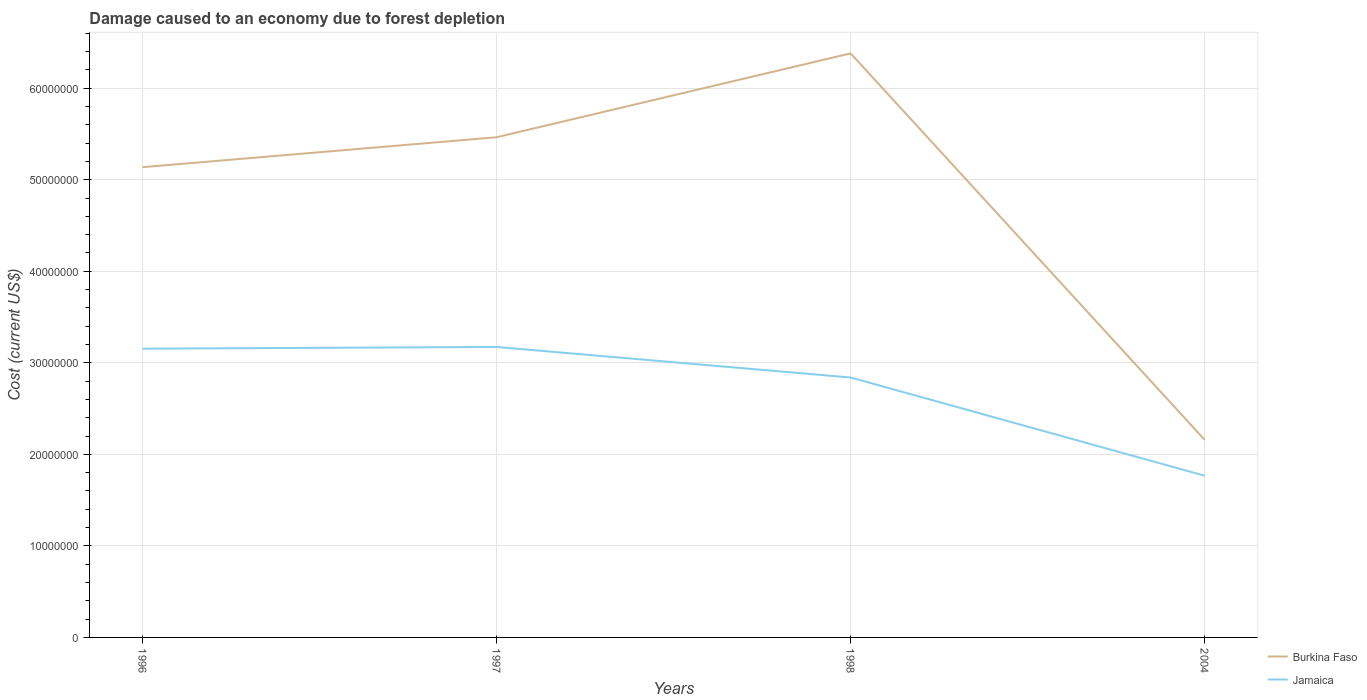How many different coloured lines are there?
Provide a succinct answer. 2. Does the line corresponding to Burkina Faso intersect with the line corresponding to Jamaica?
Give a very brief answer. No. Across all years, what is the maximum cost of damage caused due to forest depletion in Burkina Faso?
Provide a succinct answer. 2.16e+07. What is the total cost of damage caused due to forest depletion in Burkina Faso in the graph?
Give a very brief answer. 2.98e+07. What is the difference between the highest and the second highest cost of damage caused due to forest depletion in Jamaica?
Keep it short and to the point. 1.41e+07. How many lines are there?
Ensure brevity in your answer.  2. How many years are there in the graph?
Your answer should be very brief. 4. Does the graph contain any zero values?
Ensure brevity in your answer.  No. How many legend labels are there?
Your response must be concise. 2. What is the title of the graph?
Your answer should be compact. Damage caused to an economy due to forest depletion. Does "St. Lucia" appear as one of the legend labels in the graph?
Ensure brevity in your answer.  No. What is the label or title of the Y-axis?
Give a very brief answer. Cost (current US$). What is the Cost (current US$) in Burkina Faso in 1996?
Offer a terse response. 5.14e+07. What is the Cost (current US$) of Jamaica in 1996?
Your answer should be very brief. 3.15e+07. What is the Cost (current US$) of Burkina Faso in 1997?
Offer a very short reply. 5.46e+07. What is the Cost (current US$) in Jamaica in 1997?
Offer a very short reply. 3.17e+07. What is the Cost (current US$) of Burkina Faso in 1998?
Offer a terse response. 6.38e+07. What is the Cost (current US$) in Jamaica in 1998?
Provide a succinct answer. 2.84e+07. What is the Cost (current US$) in Burkina Faso in 2004?
Provide a short and direct response. 2.16e+07. What is the Cost (current US$) of Jamaica in 2004?
Provide a succinct answer. 1.77e+07. Across all years, what is the maximum Cost (current US$) in Burkina Faso?
Your response must be concise. 6.38e+07. Across all years, what is the maximum Cost (current US$) in Jamaica?
Ensure brevity in your answer.  3.17e+07. Across all years, what is the minimum Cost (current US$) of Burkina Faso?
Ensure brevity in your answer.  2.16e+07. Across all years, what is the minimum Cost (current US$) in Jamaica?
Make the answer very short. 1.77e+07. What is the total Cost (current US$) of Burkina Faso in the graph?
Provide a succinct answer. 1.91e+08. What is the total Cost (current US$) in Jamaica in the graph?
Offer a terse response. 1.09e+08. What is the difference between the Cost (current US$) in Burkina Faso in 1996 and that in 1997?
Provide a succinct answer. -3.27e+06. What is the difference between the Cost (current US$) of Jamaica in 1996 and that in 1997?
Your answer should be compact. -1.87e+05. What is the difference between the Cost (current US$) of Burkina Faso in 1996 and that in 1998?
Your answer should be very brief. -1.24e+07. What is the difference between the Cost (current US$) of Jamaica in 1996 and that in 1998?
Ensure brevity in your answer.  3.15e+06. What is the difference between the Cost (current US$) in Burkina Faso in 1996 and that in 2004?
Give a very brief answer. 2.98e+07. What is the difference between the Cost (current US$) of Jamaica in 1996 and that in 2004?
Your answer should be very brief. 1.39e+07. What is the difference between the Cost (current US$) in Burkina Faso in 1997 and that in 1998?
Offer a very short reply. -9.16e+06. What is the difference between the Cost (current US$) in Jamaica in 1997 and that in 1998?
Offer a terse response. 3.34e+06. What is the difference between the Cost (current US$) in Burkina Faso in 1997 and that in 2004?
Your answer should be very brief. 3.31e+07. What is the difference between the Cost (current US$) of Jamaica in 1997 and that in 2004?
Give a very brief answer. 1.41e+07. What is the difference between the Cost (current US$) of Burkina Faso in 1998 and that in 2004?
Your answer should be very brief. 4.22e+07. What is the difference between the Cost (current US$) in Jamaica in 1998 and that in 2004?
Your answer should be very brief. 1.07e+07. What is the difference between the Cost (current US$) in Burkina Faso in 1996 and the Cost (current US$) in Jamaica in 1997?
Your response must be concise. 1.96e+07. What is the difference between the Cost (current US$) of Burkina Faso in 1996 and the Cost (current US$) of Jamaica in 1998?
Your response must be concise. 2.30e+07. What is the difference between the Cost (current US$) in Burkina Faso in 1996 and the Cost (current US$) in Jamaica in 2004?
Your response must be concise. 3.37e+07. What is the difference between the Cost (current US$) in Burkina Faso in 1997 and the Cost (current US$) in Jamaica in 1998?
Ensure brevity in your answer.  2.62e+07. What is the difference between the Cost (current US$) in Burkina Faso in 1997 and the Cost (current US$) in Jamaica in 2004?
Your answer should be compact. 3.70e+07. What is the difference between the Cost (current US$) of Burkina Faso in 1998 and the Cost (current US$) of Jamaica in 2004?
Keep it short and to the point. 4.61e+07. What is the average Cost (current US$) of Burkina Faso per year?
Provide a succinct answer. 4.79e+07. What is the average Cost (current US$) of Jamaica per year?
Provide a succinct answer. 2.73e+07. In the year 1996, what is the difference between the Cost (current US$) in Burkina Faso and Cost (current US$) in Jamaica?
Your response must be concise. 1.98e+07. In the year 1997, what is the difference between the Cost (current US$) in Burkina Faso and Cost (current US$) in Jamaica?
Give a very brief answer. 2.29e+07. In the year 1998, what is the difference between the Cost (current US$) of Burkina Faso and Cost (current US$) of Jamaica?
Keep it short and to the point. 3.54e+07. In the year 2004, what is the difference between the Cost (current US$) in Burkina Faso and Cost (current US$) in Jamaica?
Provide a succinct answer. 3.92e+06. What is the ratio of the Cost (current US$) of Burkina Faso in 1996 to that in 1997?
Keep it short and to the point. 0.94. What is the ratio of the Cost (current US$) of Jamaica in 1996 to that in 1997?
Make the answer very short. 0.99. What is the ratio of the Cost (current US$) of Burkina Faso in 1996 to that in 1998?
Offer a very short reply. 0.81. What is the ratio of the Cost (current US$) in Jamaica in 1996 to that in 1998?
Keep it short and to the point. 1.11. What is the ratio of the Cost (current US$) in Burkina Faso in 1996 to that in 2004?
Your answer should be compact. 2.38. What is the ratio of the Cost (current US$) in Jamaica in 1996 to that in 2004?
Offer a very short reply. 1.79. What is the ratio of the Cost (current US$) in Burkina Faso in 1997 to that in 1998?
Your answer should be very brief. 0.86. What is the ratio of the Cost (current US$) of Jamaica in 1997 to that in 1998?
Your answer should be compact. 1.12. What is the ratio of the Cost (current US$) of Burkina Faso in 1997 to that in 2004?
Make the answer very short. 2.53. What is the ratio of the Cost (current US$) in Jamaica in 1997 to that in 2004?
Offer a terse response. 1.8. What is the ratio of the Cost (current US$) of Burkina Faso in 1998 to that in 2004?
Offer a terse response. 2.96. What is the ratio of the Cost (current US$) of Jamaica in 1998 to that in 2004?
Your answer should be very brief. 1.61. What is the difference between the highest and the second highest Cost (current US$) of Burkina Faso?
Your answer should be compact. 9.16e+06. What is the difference between the highest and the second highest Cost (current US$) of Jamaica?
Keep it short and to the point. 1.87e+05. What is the difference between the highest and the lowest Cost (current US$) in Burkina Faso?
Ensure brevity in your answer.  4.22e+07. What is the difference between the highest and the lowest Cost (current US$) in Jamaica?
Ensure brevity in your answer.  1.41e+07. 